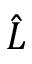<formula> <loc_0><loc_0><loc_500><loc_500>\hat { L }</formula> 